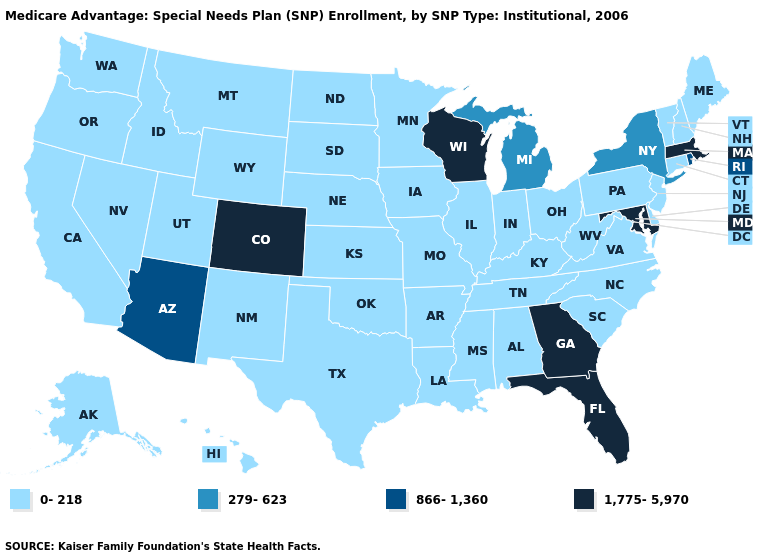Name the states that have a value in the range 866-1,360?
Be succinct. Arizona, Rhode Island. Name the states that have a value in the range 1,775-5,970?
Answer briefly. Colorado, Florida, Georgia, Massachusetts, Maryland, Wisconsin. What is the value of North Dakota?
Answer briefly. 0-218. What is the value of Missouri?
Be succinct. 0-218. What is the highest value in the USA?
Short answer required. 1,775-5,970. What is the lowest value in the West?
Answer briefly. 0-218. Among the states that border New Mexico , which have the lowest value?
Give a very brief answer. Oklahoma, Texas, Utah. What is the value of New Jersey?
Quick response, please. 0-218. Among the states that border Delaware , which have the highest value?
Answer briefly. Maryland. Name the states that have a value in the range 1,775-5,970?
Answer briefly. Colorado, Florida, Georgia, Massachusetts, Maryland, Wisconsin. What is the value of Minnesota?
Short answer required. 0-218. What is the lowest value in the USA?
Concise answer only. 0-218. Name the states that have a value in the range 279-623?
Concise answer only. Michigan, New York. What is the value of North Dakota?
Be succinct. 0-218. Does Colorado have the lowest value in the West?
Write a very short answer. No. 